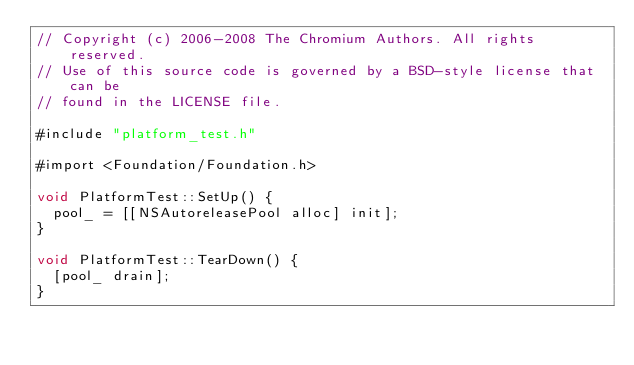Convert code to text. <code><loc_0><loc_0><loc_500><loc_500><_ObjectiveC_>// Copyright (c) 2006-2008 The Chromium Authors. All rights reserved.
// Use of this source code is governed by a BSD-style license that can be
// found in the LICENSE file.

#include "platform_test.h"

#import <Foundation/Foundation.h>

void PlatformTest::SetUp() {
  pool_ = [[NSAutoreleasePool alloc] init];
}

void PlatformTest::TearDown() {
  [pool_ drain];
}
</code> 